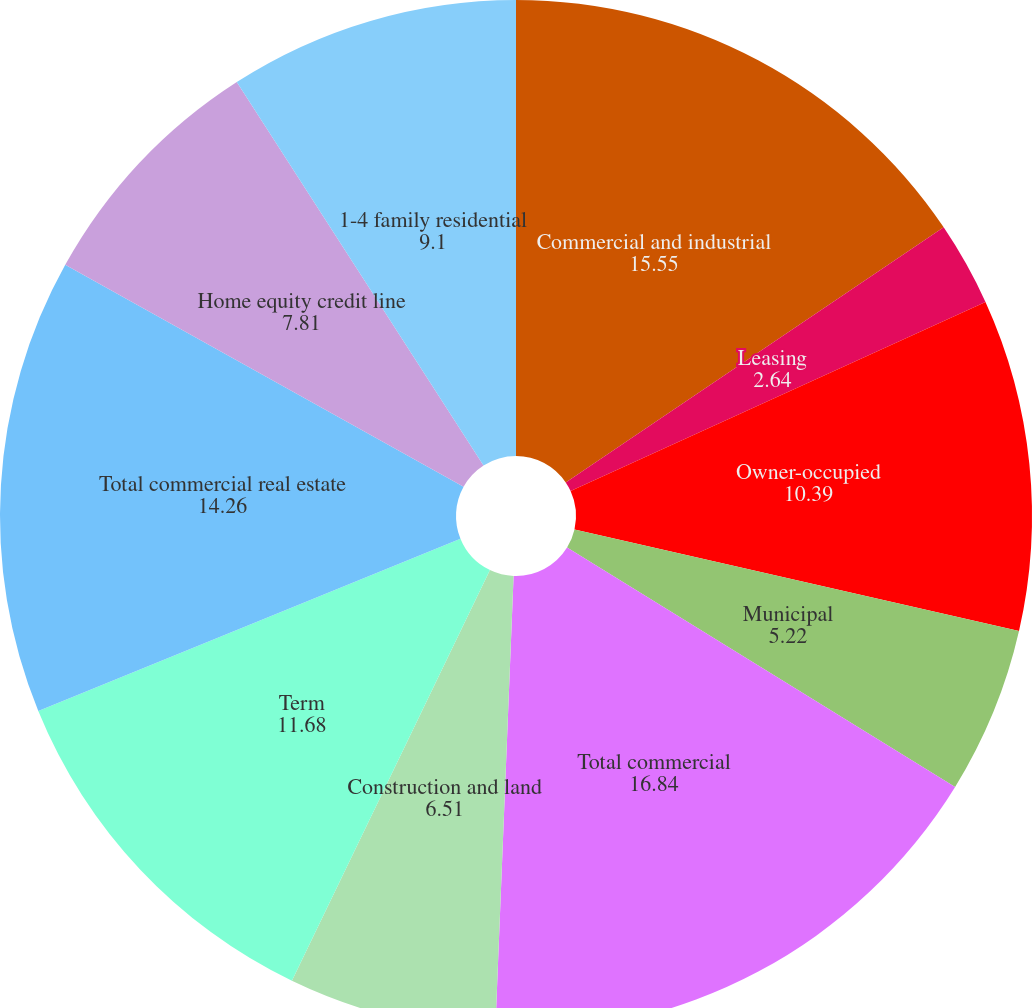Convert chart. <chart><loc_0><loc_0><loc_500><loc_500><pie_chart><fcel>Commercial and industrial<fcel>Leasing<fcel>Owner-occupied<fcel>Municipal<fcel>Total commercial<fcel>Construction and land<fcel>Term<fcel>Total commercial real estate<fcel>Home equity credit line<fcel>1-4 family residential<nl><fcel>15.55%<fcel>2.64%<fcel>10.39%<fcel>5.22%<fcel>16.84%<fcel>6.51%<fcel>11.68%<fcel>14.26%<fcel>7.81%<fcel>9.1%<nl></chart> 